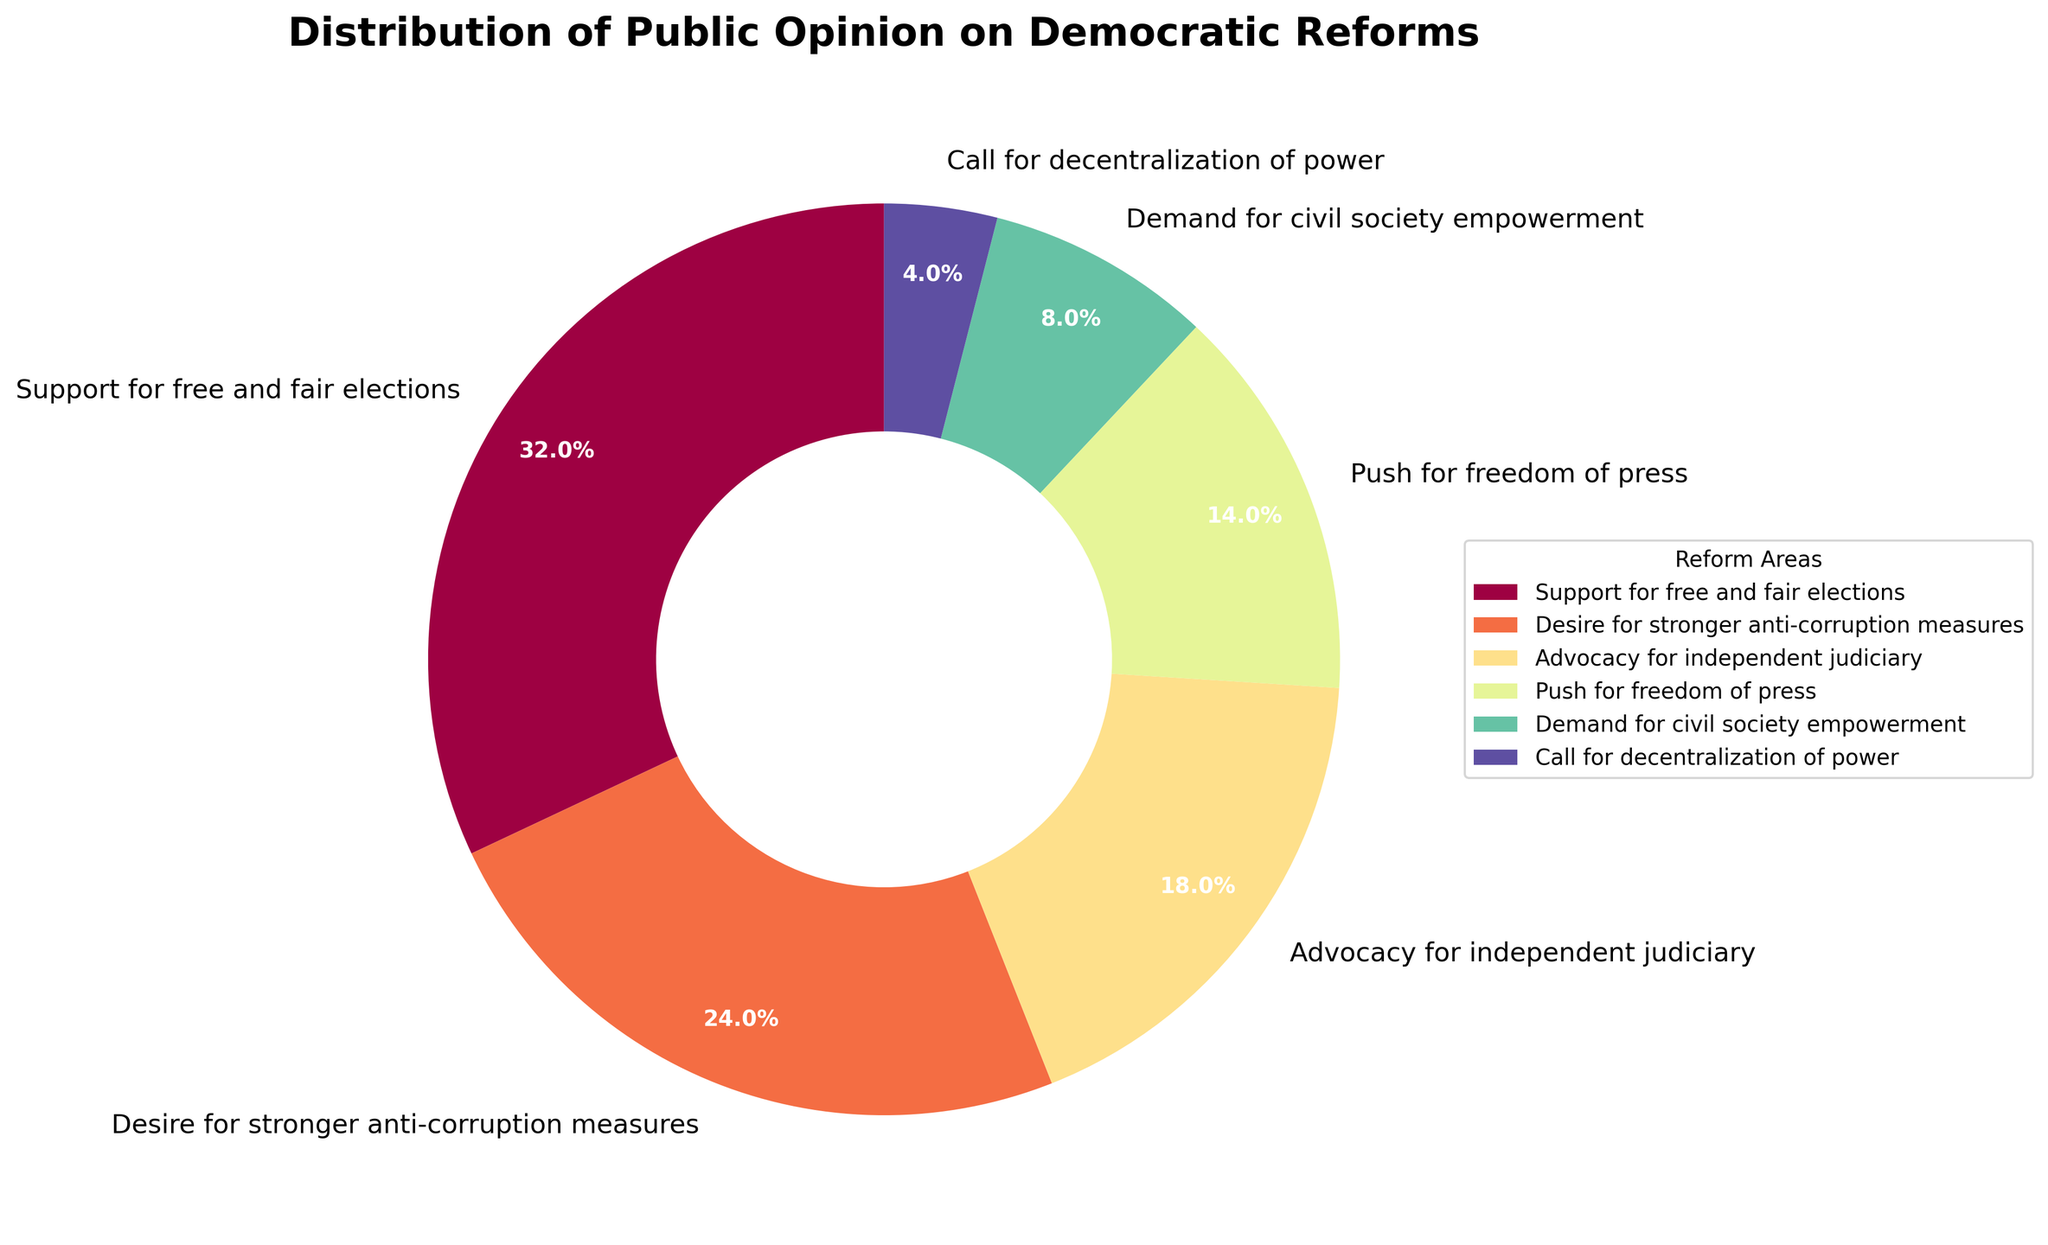What's the largest public opinion on democratic reforms? To find the largest public opinion, look at the slice with the greatest percentage. Identify the opinion associated with the largest percentage in the pie chart. Since "Support for free and fair elections" has the highest percentage at 32%, it is the largest public opinion in the chart.
Answer: Support for free and fair elections How much more support is there for free and fair elections compared to civil society empowerment? Identify the percentages for "Support for free and fair elections" (32%) and "Demand for civil society empowerment" (8%). Subtract the percentage for civil society empowerment from the percentage for free and fair elections: 32% - 8%.
Answer: 24% Which opinion has the smallest percentage? To determine the smallest percentage, look at the slice with the smallest value. Identify the opinion associated with the smallest percentage in the pie chart. The "Call for decentralization of power" has the smallest percentage at 4%.
Answer: Call for decentralization of power Which reform areas together account for over 50% of the public opinion? Identify the percentages of the largest slices and add them together until the sum is over 50%. "Support for free and fair elections" is 32% and "Desire for stronger anti-corruption measures" is 24%. Adding these two gives 32% + 24% = 56%, which is over 50%.
Answer: Support for free and fair elections and Desire for stronger anti-corruption measures By how much does the advocacy for an independent judiciary exceed the call for decentralization of power? Identify the percentages for "Advocacy for independent judiciary" (18%) and "Call for decentralization of power" (4%). Subtract the percentage for decentralization of power from the percentage for independent judiciary: 18% - 4%.
Answer: 14% How does the support for freedom of the press compare with the desire for stronger anti-corruption measures? Identify the percentages for "Push for freedom of press" (14%) and "Desire for stronger anti-corruption measures" (24%). Compare the two values to see which is higher. The "Desire for stronger anti-corruption measures" at 24% is higher than the "Push for freedom of press" at 14%.
Answer: Desire for stronger anti-corruption measures is higher What is the difference in percentage points between support for free and fair elections and push for freedom of press? Identify the percentages for "Support for free and fair elections" (32%) and "Push for freedom of press" (14%). Subtract the percentage for freedom of press from the percentage for free and fair elections: 32% - 14%.
Answer: 18% What's the total percentage of public opinion accounted for by the smaller reform areas (below 10%)? Identify the percentages of slices below 10%: "Demand for civil society empowerment" (8%) and "Call for decentralization of power" (4%). Add these percentages together: 8% + 4%.
Answer: 12% Is the percentage of advocacy for an independent judiciary closer to push for freedom of press or to demand for civil society empowerment? Identify the percentages for "Advocacy for independent judiciary" (18%), "Push for freedom of press" (14%), and "Demand for civil society empowerment" (8%). Calculate the differences: 18% - 14% = 4% and 18% - 8% = 10%. The smaller difference is 4%, making it closer to the push for freedom of press.
Answer: Push for freedom of press What is the mean percentage of all opinion categories? To find the mean percentage, sum all the percentages: 32% + 24% + 18% + 14% + 8% + 4% = 100%. Divide the sum by the number of opinion categories, which is 6: 100% / 6 = 16.67%.
Answer: 16.67% 